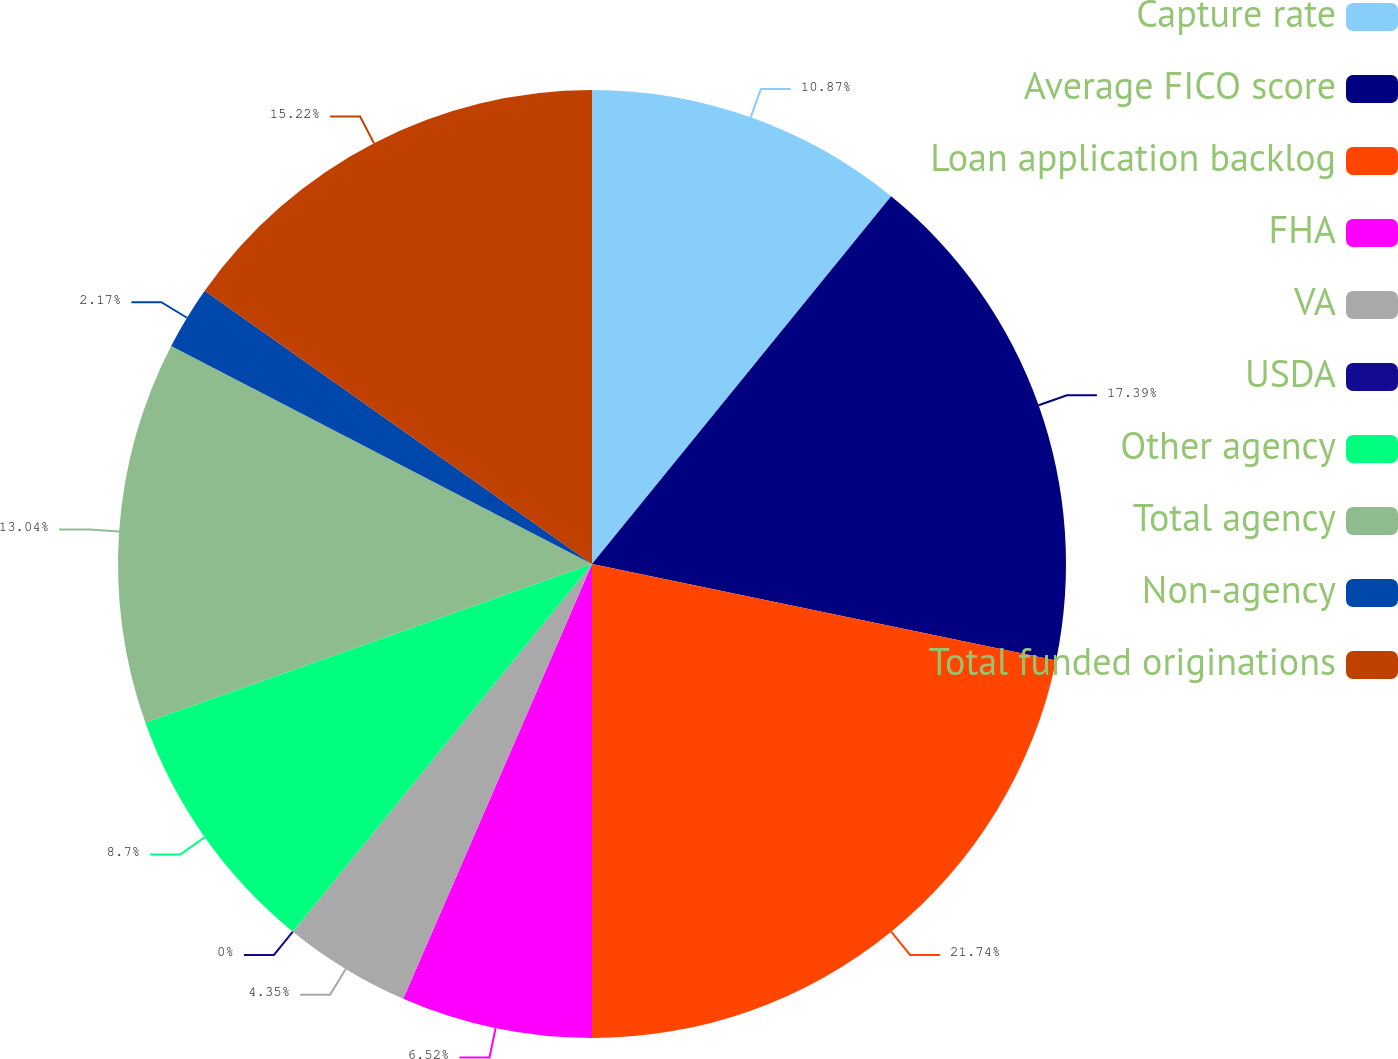Convert chart. <chart><loc_0><loc_0><loc_500><loc_500><pie_chart><fcel>Capture rate<fcel>Average FICO score<fcel>Loan application backlog<fcel>FHA<fcel>VA<fcel>USDA<fcel>Other agency<fcel>Total agency<fcel>Non-agency<fcel>Total funded originations<nl><fcel>10.87%<fcel>17.39%<fcel>21.74%<fcel>6.52%<fcel>4.35%<fcel>0.0%<fcel>8.7%<fcel>13.04%<fcel>2.17%<fcel>15.22%<nl></chart> 